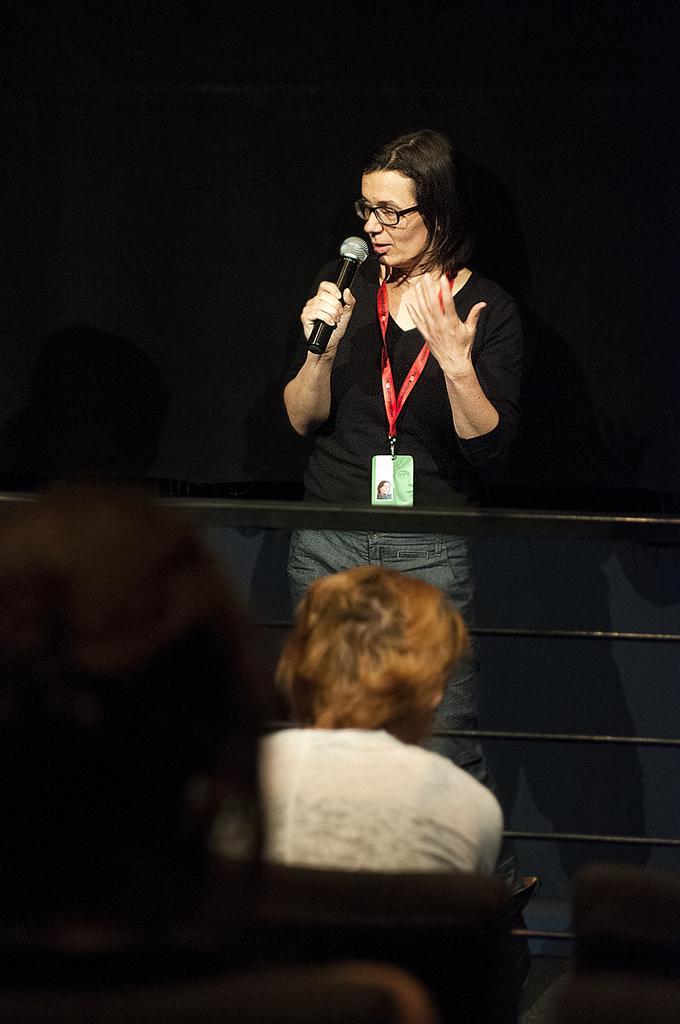Describe this image in one or two sentences. There is a woman standing on stage is speaking on a microphone behind her there are few other people sitting and staring at her. 